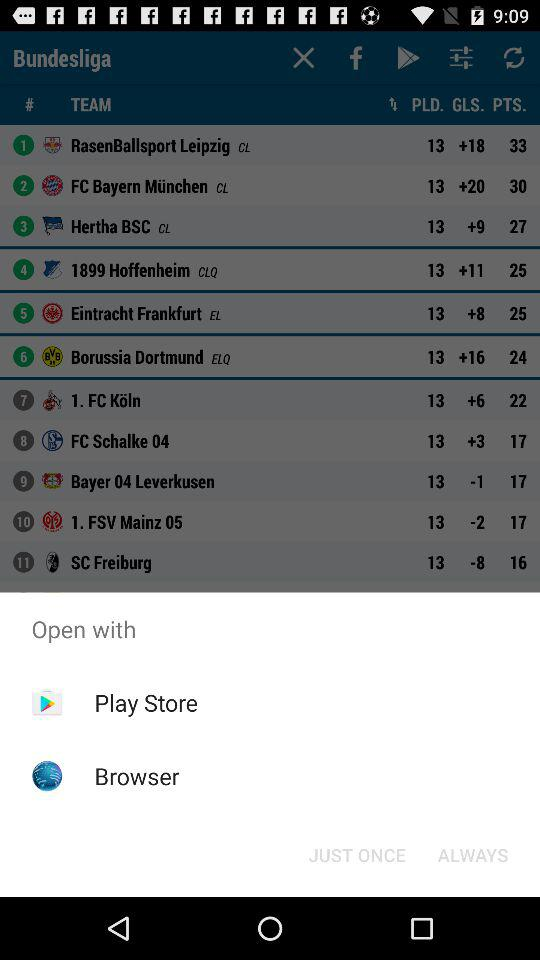Which team has the lowest number of points?
Answer the question using a single word or phrase. SC Freiburg 